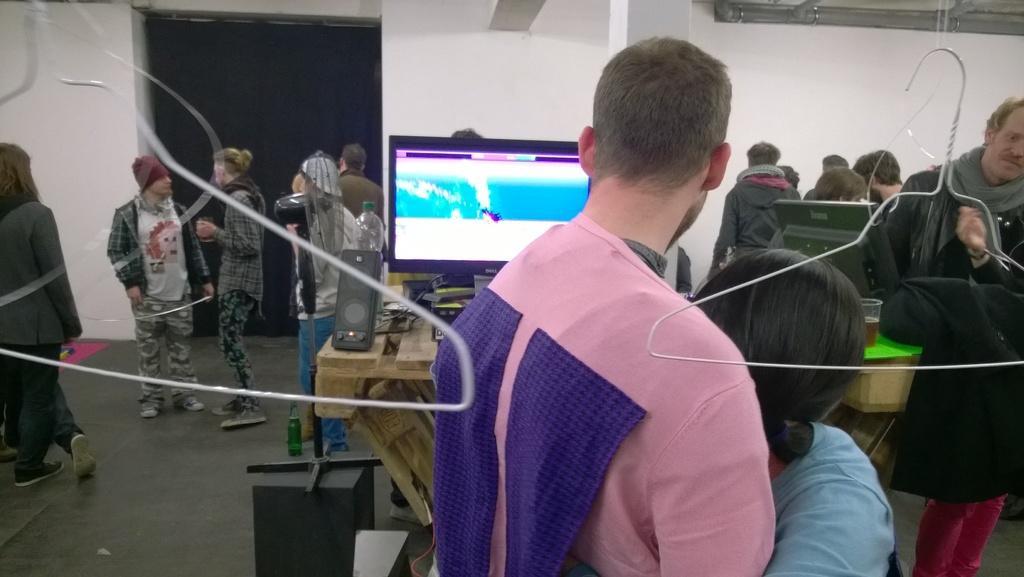Please provide a concise description of this image. In this picture there is a man wearing pink color t-shirt standing in the front and a woman wearing blue color t-shirt is holding him in the arms. Behind there is a computer screen and speakers. In the background we can see some persons are standing and a big white wall. 